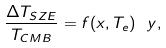<formula> <loc_0><loc_0><loc_500><loc_500>\frac { \Delta T _ { S Z E } } { T _ { C M B } } = f ( x , T _ { e } ) \ y ,</formula> 